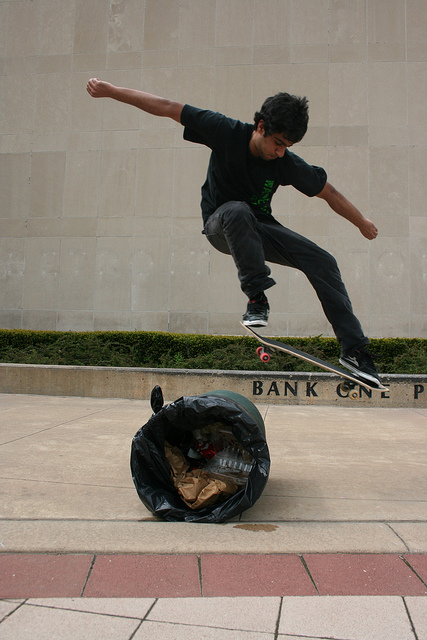Extract all visible text content from this image. BANK ONE P 